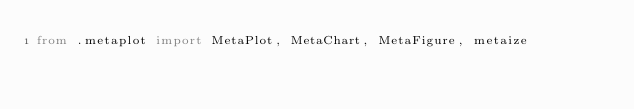<code> <loc_0><loc_0><loc_500><loc_500><_Python_>from .metaplot import MetaPlot, MetaChart, MetaFigure, metaize

</code> 